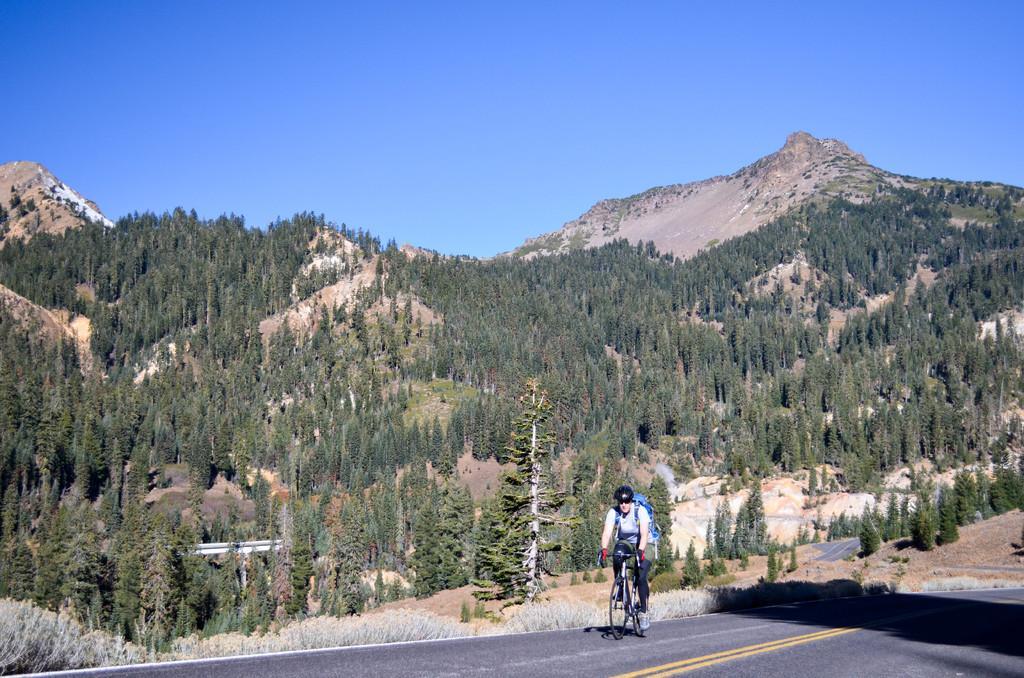Can you describe this image briefly? In the image there is a person cycling on the road and behind there is hill covered with trees all over it and above its sky. 